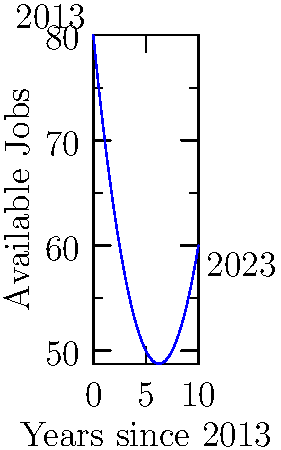The graph shows the number of available jobs in your town over the past decade (2013-2023). The function representing this trend is given by $f(x) = 80 - 10x + 0.8x^2$, where $x$ is the number of years since 2013. Calculate the total number of job-years (area under the curve) available in your town during this period. Round your answer to the nearest whole number. To find the area under the curve, we need to integrate the function $f(x)$ from $x=0$ to $x=10$:

1) Set up the integral:
   $$\int_0^{10} (80 - 10x + 0.8x^2) dx$$

2) Integrate each term:
   $$\left[80x - 5x^2 + \frac{0.8}{3}x^3\right]_0^{10}$$

3) Evaluate at the upper and lower bounds:
   $$(800 - 500 + \frac{800}{3}) - (0 - 0 + 0)$$

4) Simplify:
   $$800 - 500 + \frac{800}{3} = 300 + \frac{800}{3} = 300 + 266.67$$

5) Sum up:
   $$566.67$$

6) Round to the nearest whole number:
   $$567$$

Therefore, the total number of job-years available in your town during this period is approximately 567.
Answer: 567 job-years 